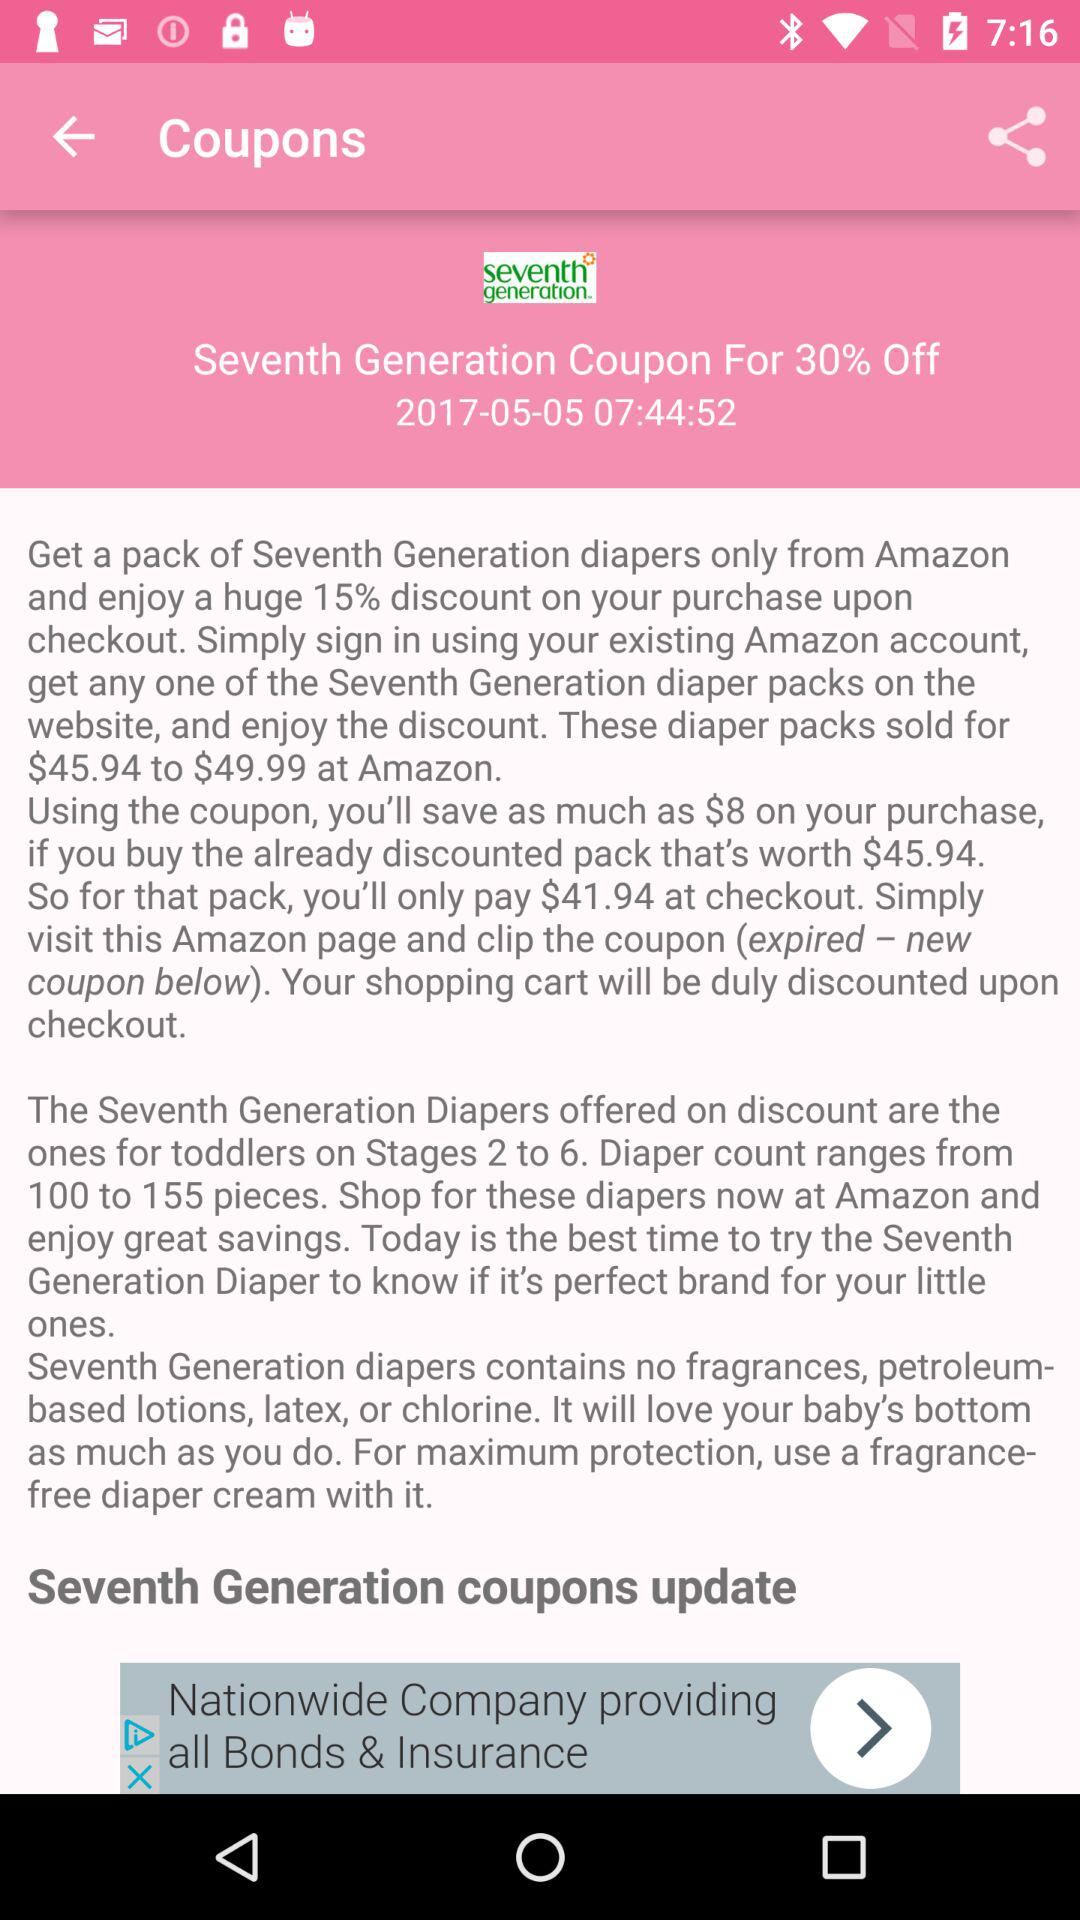Till what date is the coupon valid? The coupon is valid till May 5, 2017. 